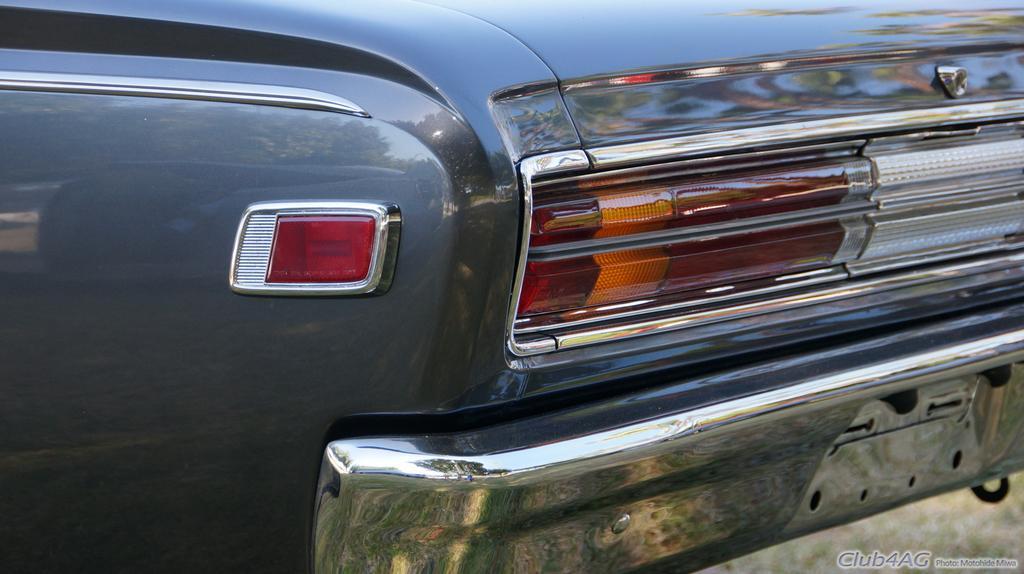Please provide a concise description of this image. This image is taken outdoors. In this image there is a car. The car is gray in color. 